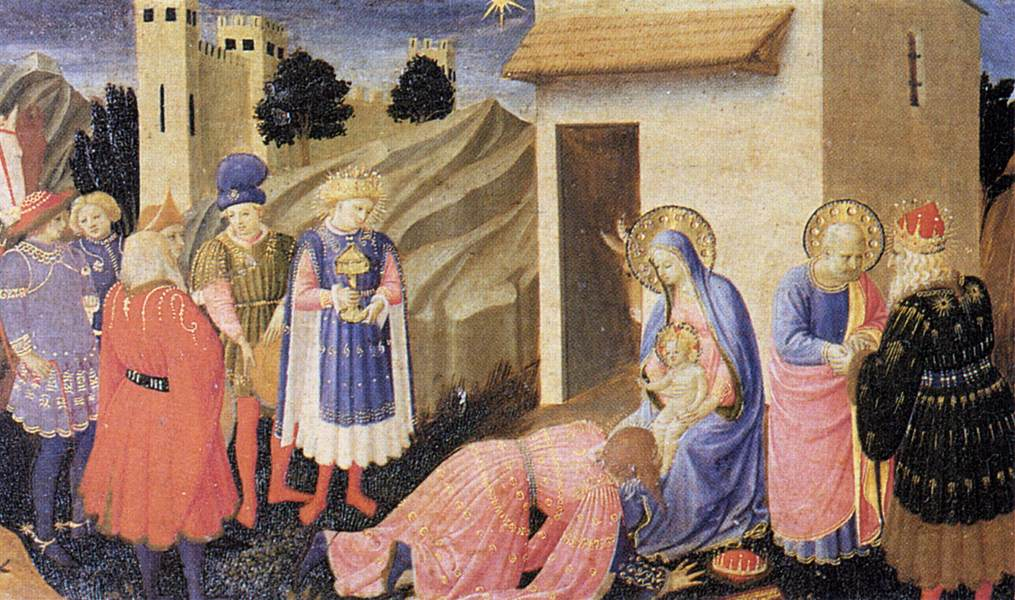If you could add an element to this painting, what would it be and why? If I could add an element to this painting, I would include a choir of angels in the sky, subtly singing praises. This addition would amplify the divine and miraculous atmosphere of the scene by incorporating heavenly beings actively participating in the celebration of Christ's birth. It would enhance the narrative of the scene, showing that the event is not just significant to those on Earth but also a moment of great importance in the heavenly realm. 